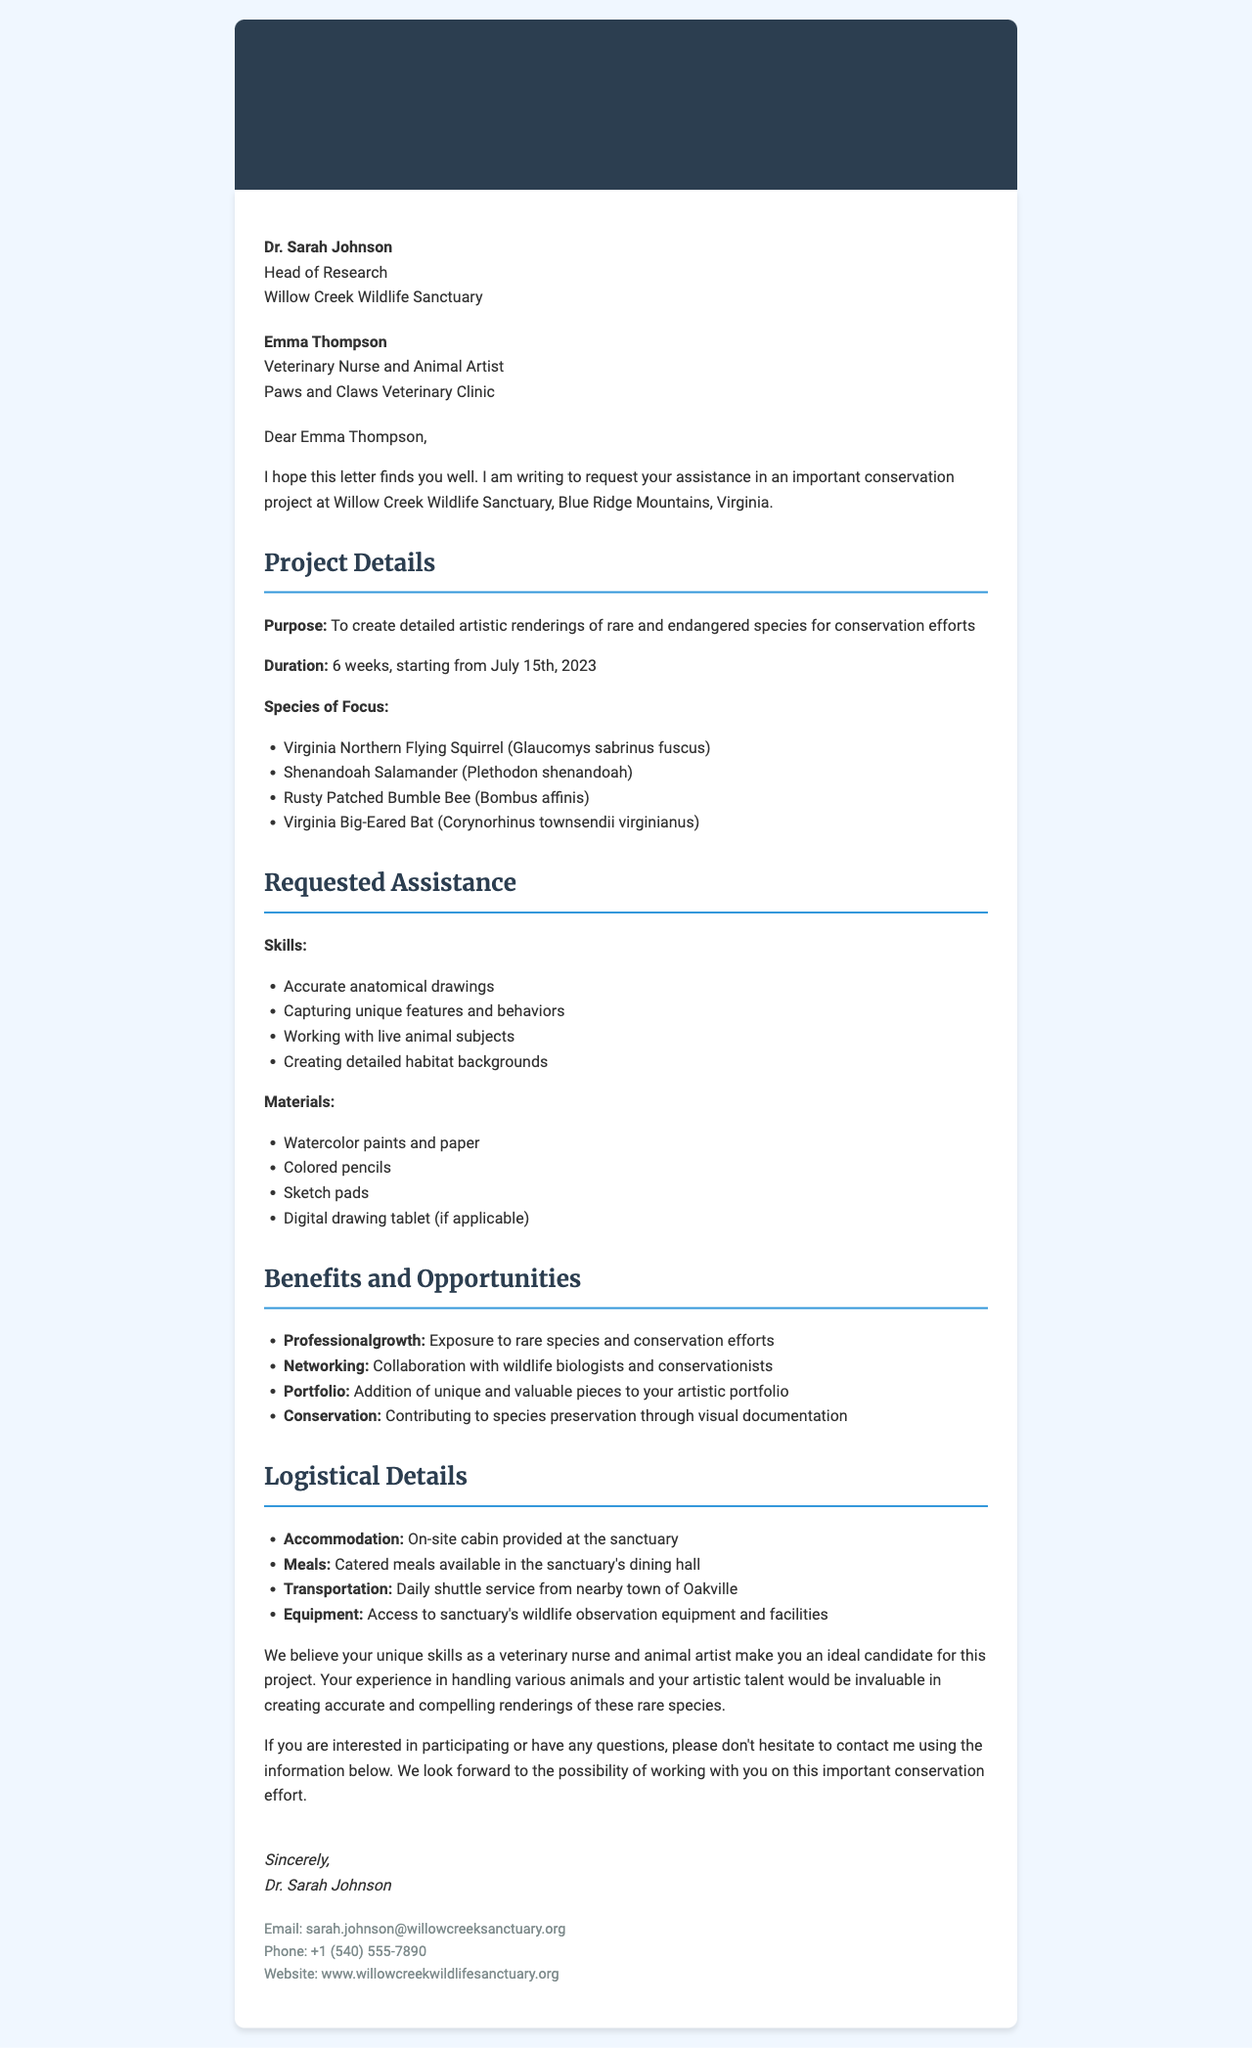What is the sender's name? The sender's name is mentioned at the top of the letter as Dr. Sarah Johnson.
Answer: Dr. Sarah Johnson What is the duration of the project? The duration of the project is explicitly provided in the details section.
Answer: 6 weeks Which species is included in the project? The species included are listed in a bullet point format in the project details.
Answer: Virginia Northern Flying Squirrel (Glaucomys sabrinus fuscus) What skills are requested for assistance? The skills needed are detailed in a specific section within the letter.
Answer: Accurate anatomical drawings What accommodation is provided? The accommodation details are listed in the logistical details section of the letter.
Answer: On-site cabin How many species are listed for documentation? The number of species can be counted from the provided list in the project details.
Answer: 4 species What is the main purpose of the project? The main purpose is clearly stated at the beginning of the project details.
Answer: Create detailed artistic renderings of rare and endangered species Which email address can be used to contact the sender? The email address for contact is provided in the contact information section.
Answer: sarah.johnson@willowcreeksanctuary.org What benefits does participating in the project provide? Benefits are outlined in a dedicated section, summarizing various opportunities.
Answer: Exposure to rare species and conservation efforts 